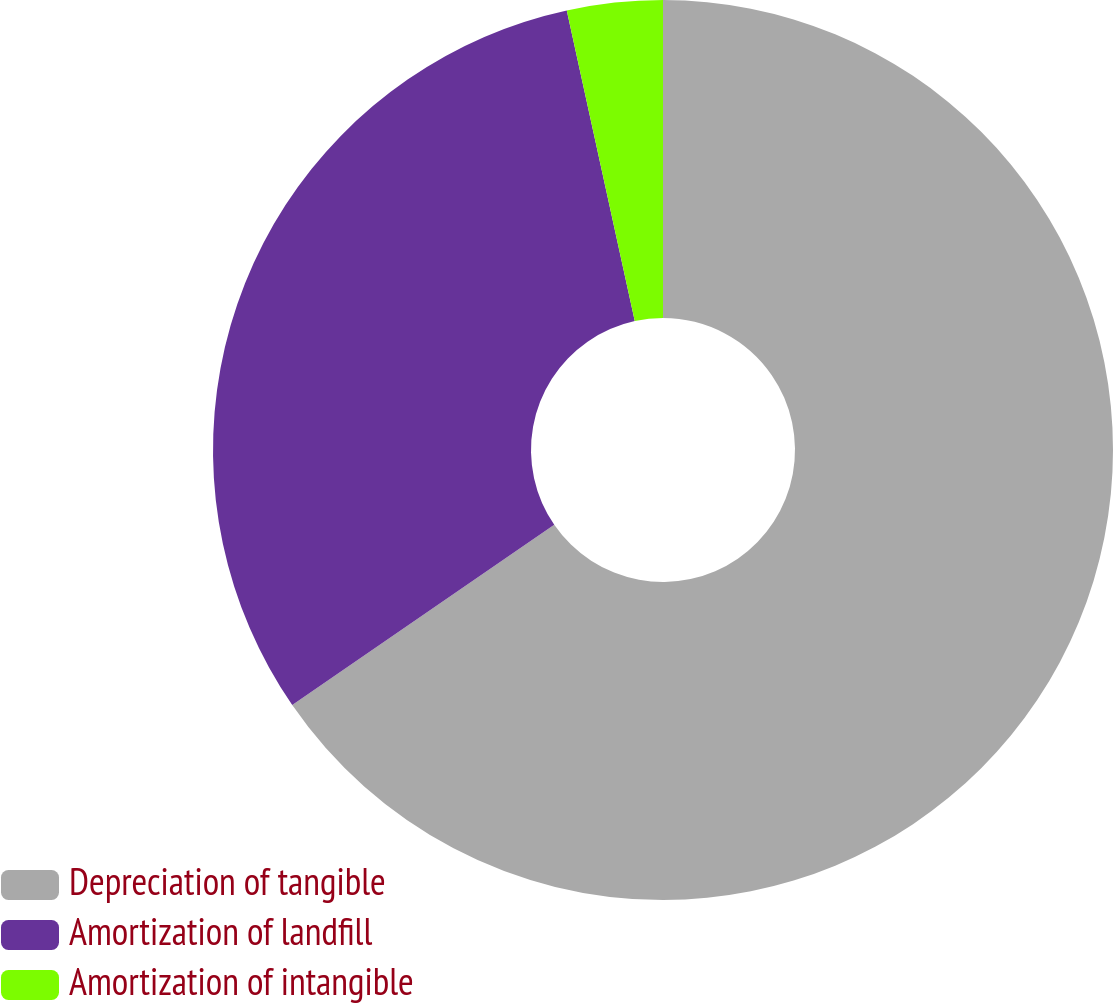<chart> <loc_0><loc_0><loc_500><loc_500><pie_chart><fcel>Depreciation of tangible<fcel>Amortization of landfill<fcel>Amortization of intangible<nl><fcel>65.41%<fcel>31.16%<fcel>3.43%<nl></chart> 